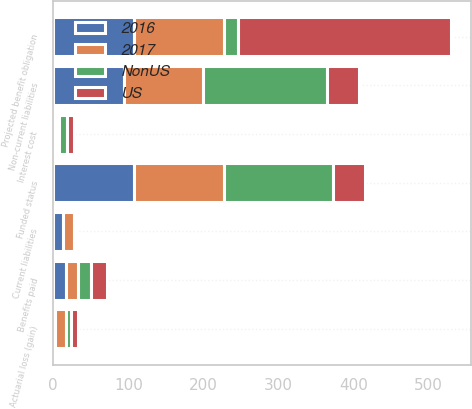Convert chart to OTSL. <chart><loc_0><loc_0><loc_500><loc_500><stacked_bar_chart><ecel><fcel>Projected benefit obligation<fcel>Interest cost<fcel>Actuarial loss (gain)<fcel>Benefits paid<fcel>Funded status<fcel>Current liabilities<fcel>Non-current liabilities<nl><fcel>US<fcel>283.3<fcel>8.9<fcel>8.7<fcel>20.8<fcel>43.2<fcel>0.1<fcel>43.1<nl><fcel>NonUS<fcel>19.25<fcel>11<fcel>7.8<fcel>17.6<fcel>145.4<fcel>3.9<fcel>164.7<nl><fcel>2016<fcel>107<fcel>3.2<fcel>2.2<fcel>17.7<fcel>107<fcel>13.2<fcel>93.8<nl><fcel>2017<fcel>119.9<fcel>4<fcel>14.4<fcel>15.2<fcel>119.9<fcel>14.5<fcel>105.4<nl></chart> 